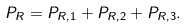Convert formula to latex. <formula><loc_0><loc_0><loc_500><loc_500>P _ { R } = P _ { R , 1 } + P _ { R , 2 } + P _ { R , 3 } .</formula> 